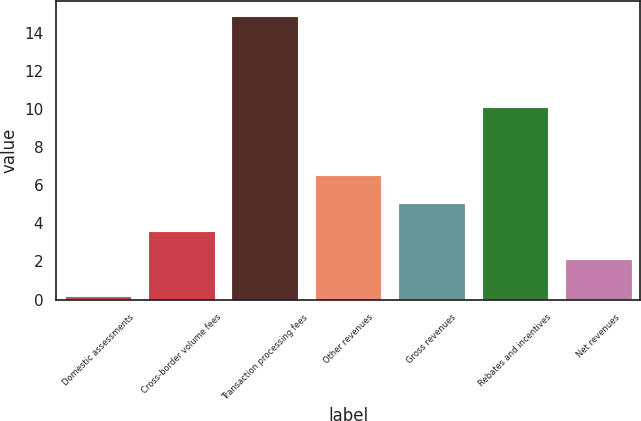Convert chart. <chart><loc_0><loc_0><loc_500><loc_500><bar_chart><fcel>Domestic assessments<fcel>Cross-border volume fees<fcel>Transaction processing fees<fcel>Other revenues<fcel>Gross revenues<fcel>Rebates and incentives<fcel>Net revenues<nl><fcel>0.2<fcel>3.57<fcel>14.9<fcel>6.51<fcel>5.04<fcel>10.1<fcel>2.1<nl></chart> 